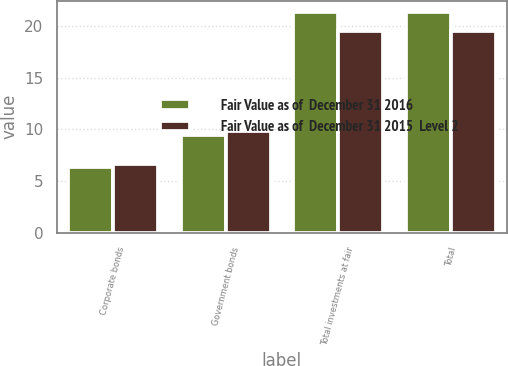Convert chart to OTSL. <chart><loc_0><loc_0><loc_500><loc_500><stacked_bar_chart><ecel><fcel>Corporate bonds<fcel>Government bonds<fcel>Total investments at fair<fcel>Total<nl><fcel>Fair Value as of  December 31 2016<fcel>6.4<fcel>9.5<fcel>21.4<fcel>21.4<nl><fcel>Fair Value as of  December 31 2015  Level 2<fcel>6.6<fcel>9.8<fcel>19.5<fcel>19.5<nl></chart> 